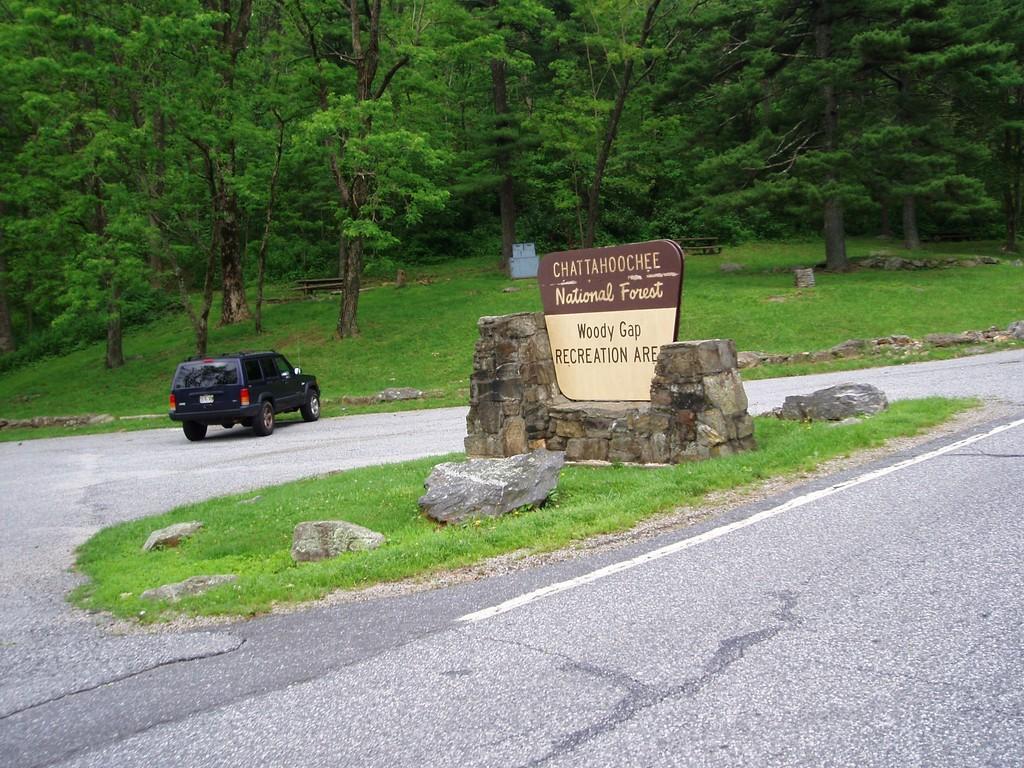In one or two sentences, can you explain what this image depicts? In the background we can see trees and grass. Here we can see a board on a stone platform. Here we can see a vehicle on the road. 